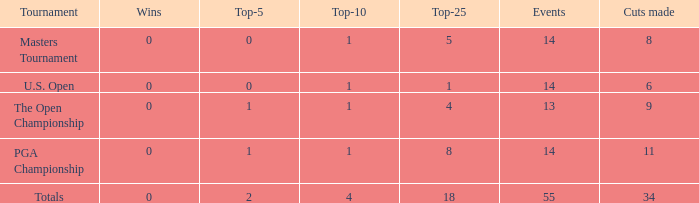What is the sum of wins when events is 13 and top-5 is less than 1? None. 